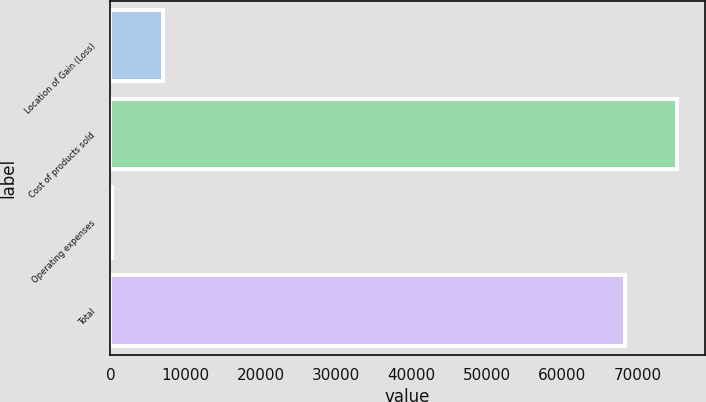<chart> <loc_0><loc_0><loc_500><loc_500><bar_chart><fcel>Location of Gain (Loss)<fcel>Cost of products sold<fcel>Operating expenses<fcel>Total<nl><fcel>7017.4<fcel>75156.4<fcel>185<fcel>68324<nl></chart> 